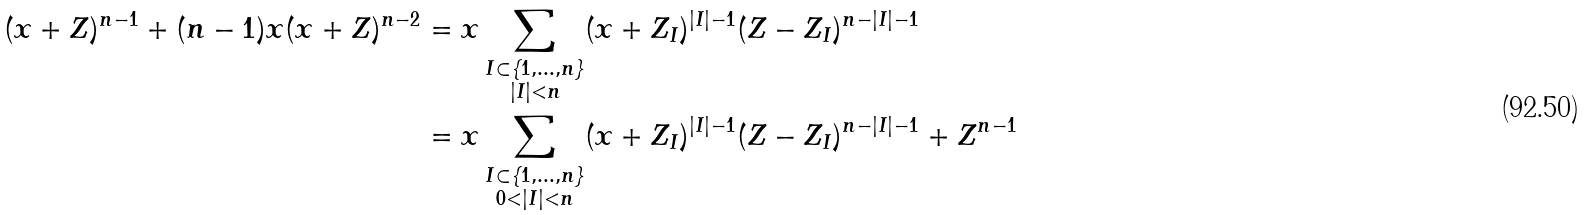Convert formula to latex. <formula><loc_0><loc_0><loc_500><loc_500>( x + Z ) ^ { n - 1 } + ( n - 1 ) x ( x + Z ) ^ { n - 2 } & = x \sum _ { \substack { I \subset \{ 1 , \dots , n \} \\ | I | < n } } ( x + Z _ { I } ) ^ { | I | - 1 } ( Z - Z _ { I } ) ^ { n - | I | - 1 } \\ & = x \sum _ { \substack { I \subset \{ 1 , \dots , n \} \\ 0 < | I | < n } } ( x + Z _ { I } ) ^ { | I | - 1 } ( Z - Z _ { I } ) ^ { n - | I | - 1 } + Z ^ { n - 1 }</formula> 